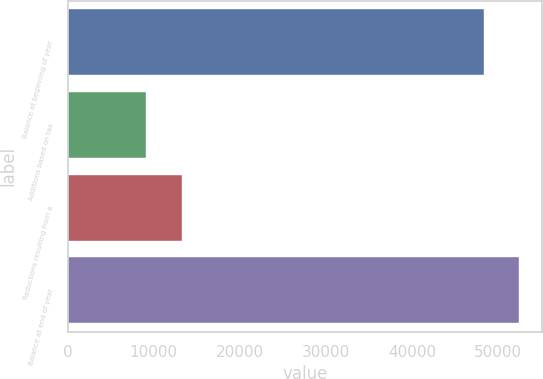Convert chart. <chart><loc_0><loc_0><loc_500><loc_500><bar_chart><fcel>Balance at beginning of year<fcel>Additions based on tax<fcel>Reductions resulting from a<fcel>Balance at end of year<nl><fcel>48306<fcel>9133<fcel>13286.5<fcel>52459.5<nl></chart> 